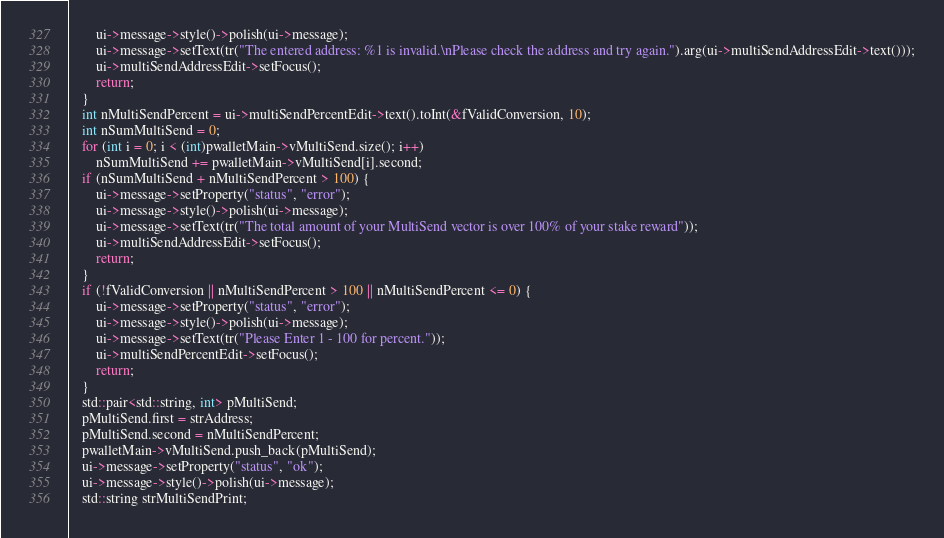Convert code to text. <code><loc_0><loc_0><loc_500><loc_500><_C++_>        ui->message->style()->polish(ui->message);
        ui->message->setText(tr("The entered address: %1 is invalid.\nPlease check the address and try again.").arg(ui->multiSendAddressEdit->text()));
        ui->multiSendAddressEdit->setFocus();
        return;
    }
    int nMultiSendPercent = ui->multiSendPercentEdit->text().toInt(&fValidConversion, 10);
    int nSumMultiSend = 0;
    for (int i = 0; i < (int)pwalletMain->vMultiSend.size(); i++)
        nSumMultiSend += pwalletMain->vMultiSend[i].second;
    if (nSumMultiSend + nMultiSendPercent > 100) {
        ui->message->setProperty("status", "error");
        ui->message->style()->polish(ui->message);
        ui->message->setText(tr("The total amount of your MultiSend vector is over 100% of your stake reward"));
        ui->multiSendAddressEdit->setFocus();
        return;
    }
    if (!fValidConversion || nMultiSendPercent > 100 || nMultiSendPercent <= 0) {
        ui->message->setProperty("status", "error");
        ui->message->style()->polish(ui->message);
        ui->message->setText(tr("Please Enter 1 - 100 for percent."));
        ui->multiSendPercentEdit->setFocus();
        return;
    }
    std::pair<std::string, int> pMultiSend;
    pMultiSend.first = strAddress;
    pMultiSend.second = nMultiSendPercent;
    pwalletMain->vMultiSend.push_back(pMultiSend);
    ui->message->setProperty("status", "ok");
    ui->message->style()->polish(ui->message);
    std::string strMultiSendPrint;</code> 